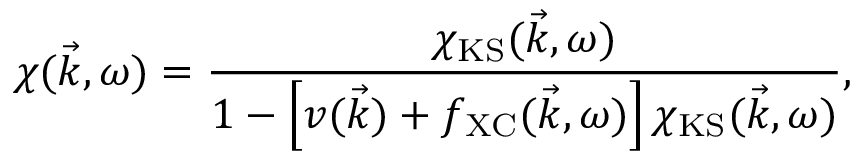Convert formula to latex. <formula><loc_0><loc_0><loc_500><loc_500>\chi ( \vec { k } , \omega ) = \frac { \chi _ { K S } ( \vec { k } , \omega ) } { 1 - \left [ v ( \vec { k } ) + f _ { X C } ( \vec { k } , \omega ) \right ] \chi _ { K S } ( \vec { k } , \omega ) } ,</formula> 